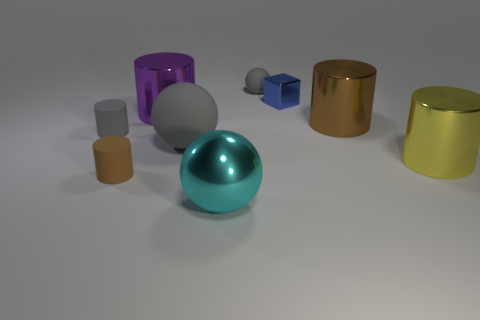Can you explain the composition of objects in the image? Certainly! The image shows a variety of geometric shapes arranged in no particular order on a flat surface. There appears to be two sets of objects: one with larger pieces including a teal sphere, a purple transparent cylinder, and a gold cylinder, and another set with smaller objects, like a small gray cylinder and a tiny blue cube. The arrangement seems random yet balanced, with colors and sizes that suggest a study of forms and textures. Do the objects seem to be made of different materials? Yes, they do. Based on their appearances, we can infer the presence of various materials: the teal sphere has a polished, perhaps metallic look, while the purple cylinder seems to be made of translucent glass or plastic. The gold cylinder might be a brushed metal, and the small blue cube looks matte, perhaps indicative of a solid, non-reflective plastic or painted wood. 